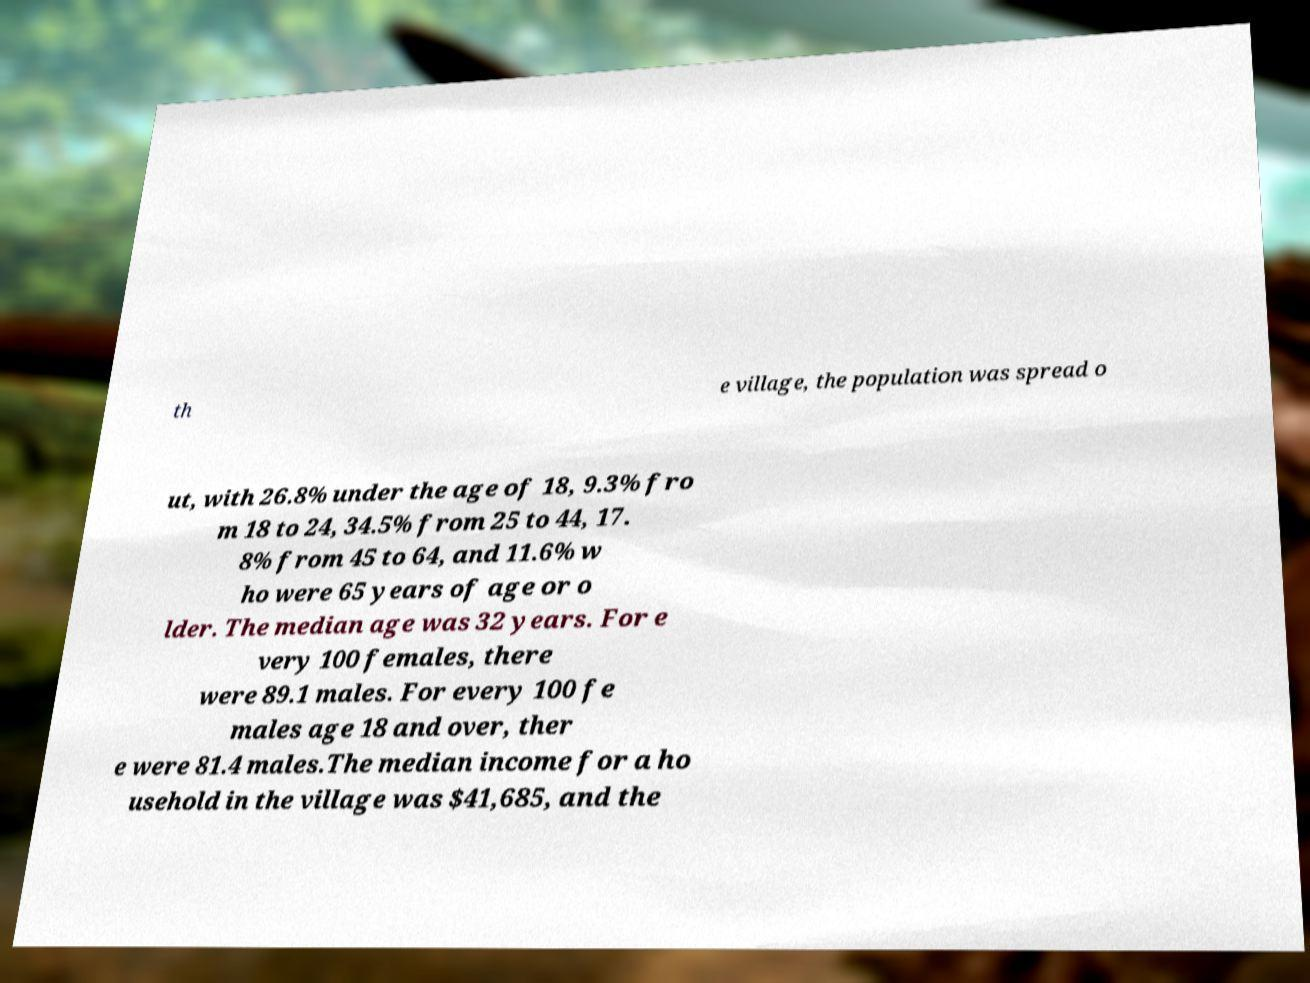Could you assist in decoding the text presented in this image and type it out clearly? th e village, the population was spread o ut, with 26.8% under the age of 18, 9.3% fro m 18 to 24, 34.5% from 25 to 44, 17. 8% from 45 to 64, and 11.6% w ho were 65 years of age or o lder. The median age was 32 years. For e very 100 females, there were 89.1 males. For every 100 fe males age 18 and over, ther e were 81.4 males.The median income for a ho usehold in the village was $41,685, and the 